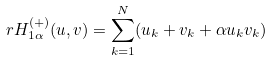<formula> <loc_0><loc_0><loc_500><loc_500>\ r H _ { 1 \alpha } ^ { ( + ) } ( u , v ) = \sum _ { k = 1 } ^ { N } ( u _ { k } + v _ { k } + \alpha u _ { k } v _ { k } )</formula> 